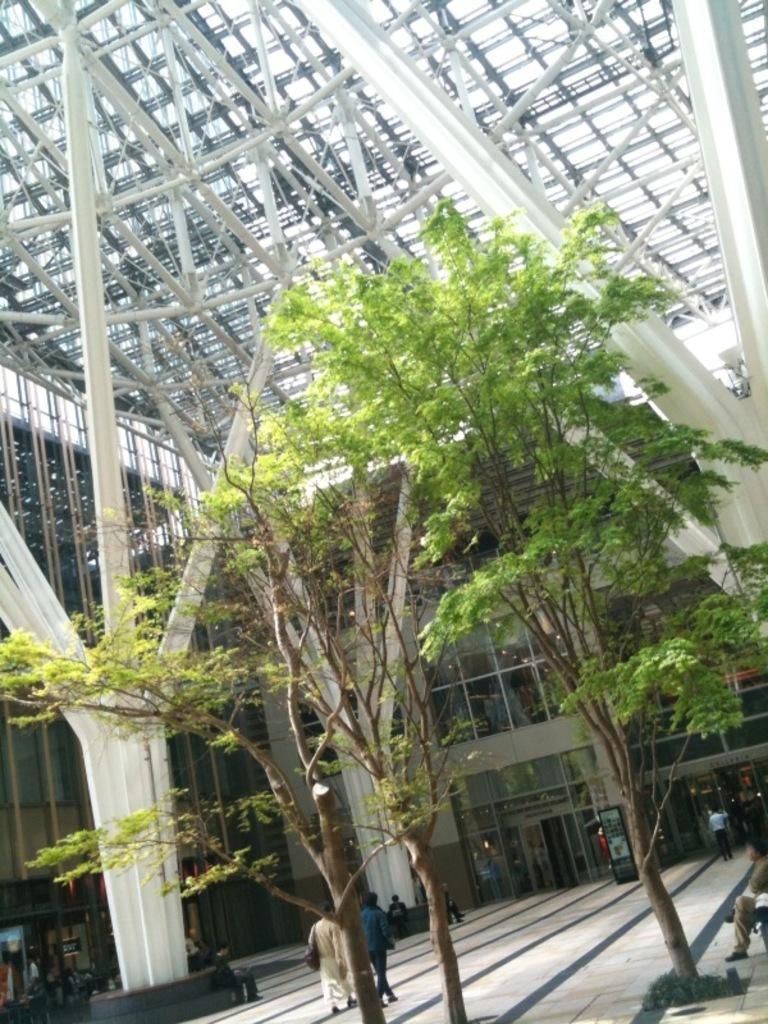What type of natural elements can be seen in the image? There are trees in the image. What architectural features are present in the image? There are pillars in the image. What are the people in the image doing? Some people are sitting, while others are walking on a path. What can be seen in the background of the image? There is a building visible in the background of the image. What type of hair can be seen on the trees in the image? Trees do not have hair; they have leaves and branches. Can you tell me how many times the people are kicking a ball in the image? There is no ball or kicking activity present in the image. 